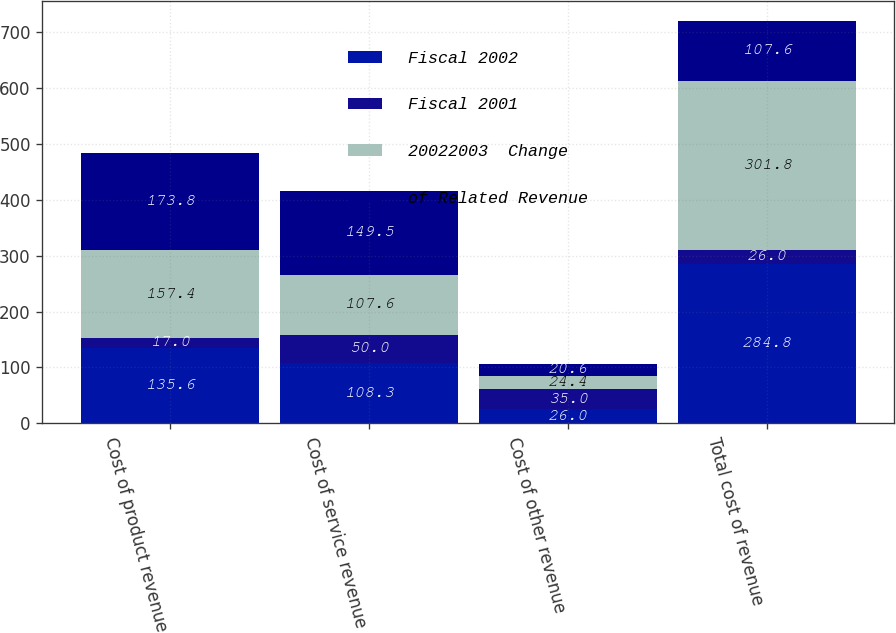<chart> <loc_0><loc_0><loc_500><loc_500><stacked_bar_chart><ecel><fcel>Cost of product revenue<fcel>Cost of service revenue<fcel>Cost of other revenue<fcel>Total cost of revenue<nl><fcel>Fiscal 2002<fcel>135.6<fcel>108.3<fcel>26<fcel>284.8<nl><fcel>Fiscal 2001<fcel>17<fcel>50<fcel>35<fcel>26<nl><fcel>20022003  Change<fcel>157.4<fcel>107.6<fcel>24.4<fcel>301.8<nl><fcel>of Related Revenue<fcel>173.8<fcel>149.5<fcel>20.6<fcel>107.6<nl></chart> 